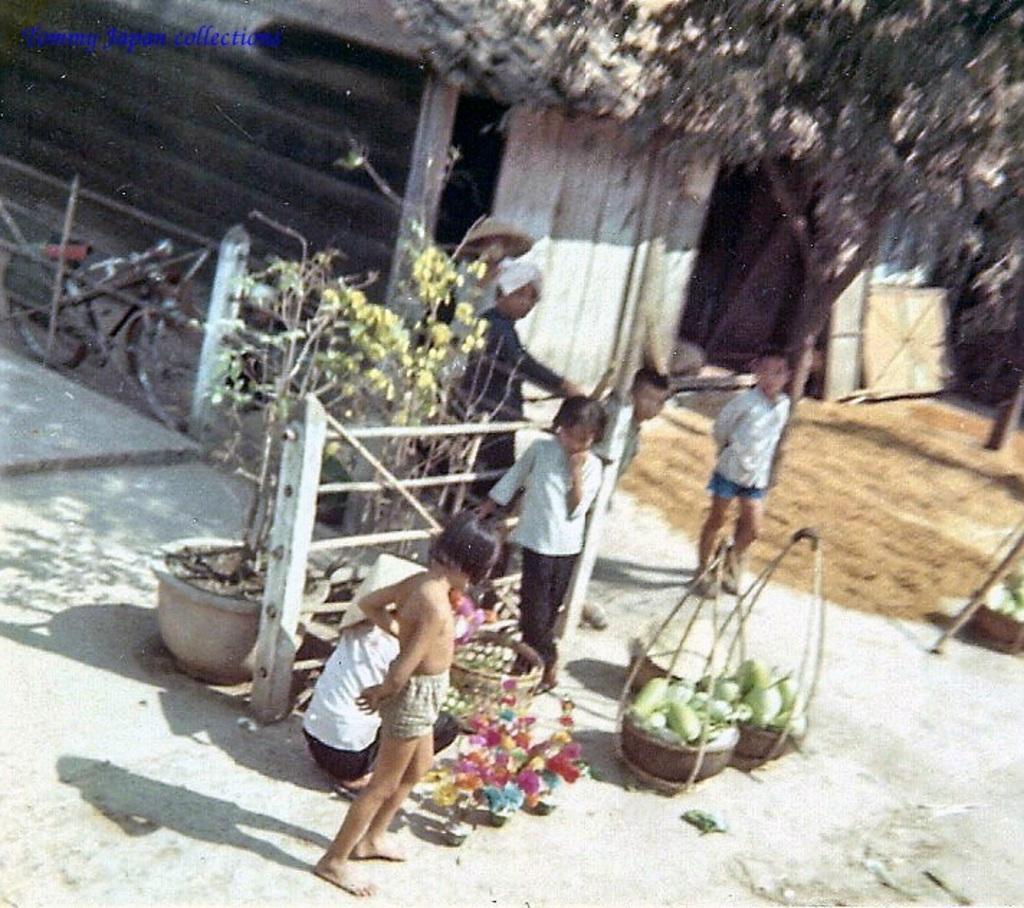Describe this image in one or two sentences. In this picture we can see a few vegetables in the baskets. There are some flower pots on the path. We can see a few bicycles. We can see a house and a tree in the background. 